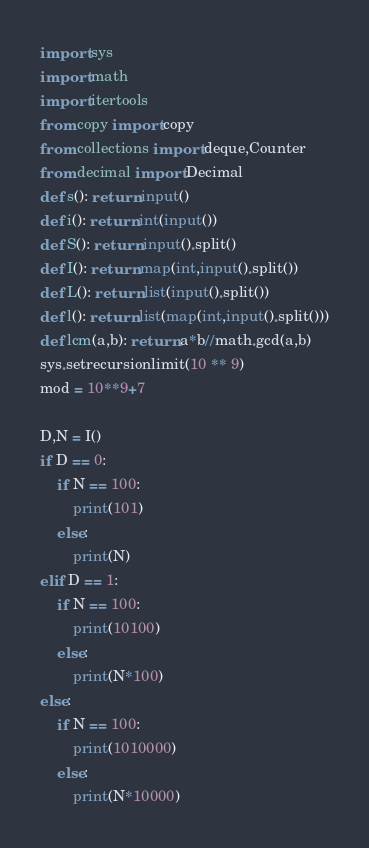<code> <loc_0><loc_0><loc_500><loc_500><_Python_>import sys
import math
import itertools
from copy import copy
from collections import deque,Counter
from decimal import Decimal
def s(): return input()
def i(): return int(input())
def S(): return input().split()
def I(): return map(int,input().split())
def L(): return list(input().split())
def l(): return list(map(int,input().split()))
def lcm(a,b): return a*b//math.gcd(a,b)
sys.setrecursionlimit(10 ** 9)
mod = 10**9+7

D,N = I()
if D == 0:
    if N == 100:
        print(101)
    else:
        print(N)
elif D == 1:
    if N == 100:
        print(10100)
    else:
        print(N*100)
else:
    if N == 100:
        print(1010000)
    else:
        print(N*10000)</code> 